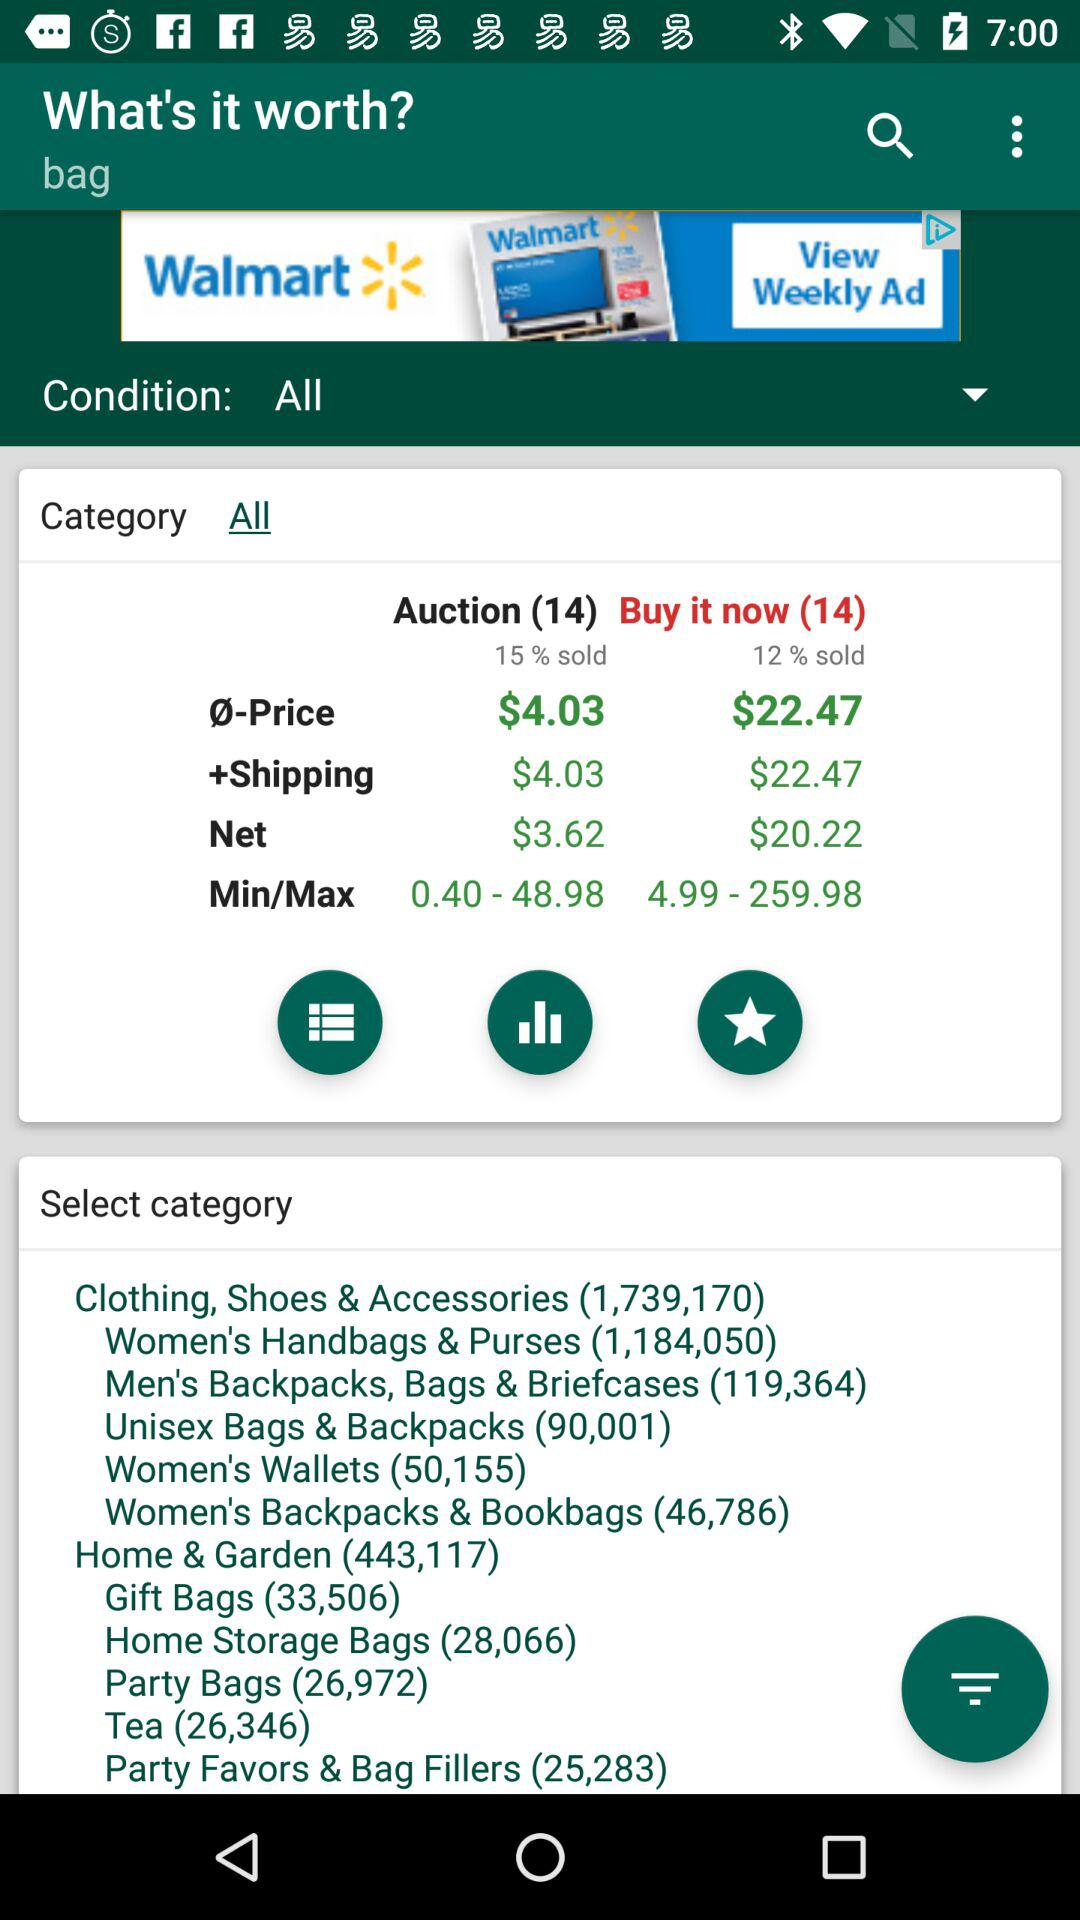What is the price range of "Min/Max" for auction? The price range of "Min/Max" is from $0.40 to $48.98. 